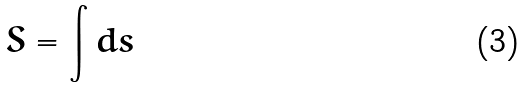<formula> <loc_0><loc_0><loc_500><loc_500>S = \int d s</formula> 